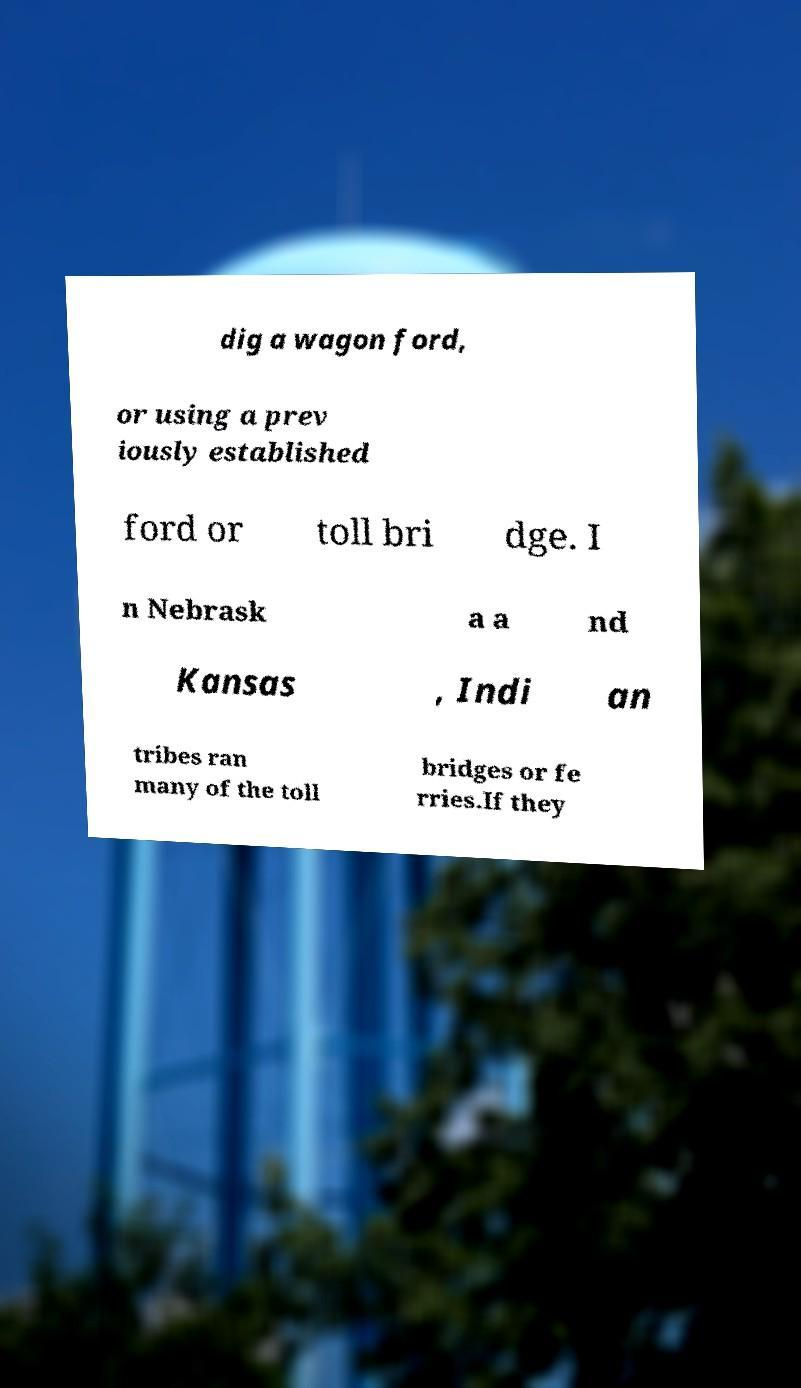Can you read and provide the text displayed in the image?This photo seems to have some interesting text. Can you extract and type it out for me? dig a wagon ford, or using a prev iously established ford or toll bri dge. I n Nebrask a a nd Kansas , Indi an tribes ran many of the toll bridges or fe rries.If they 